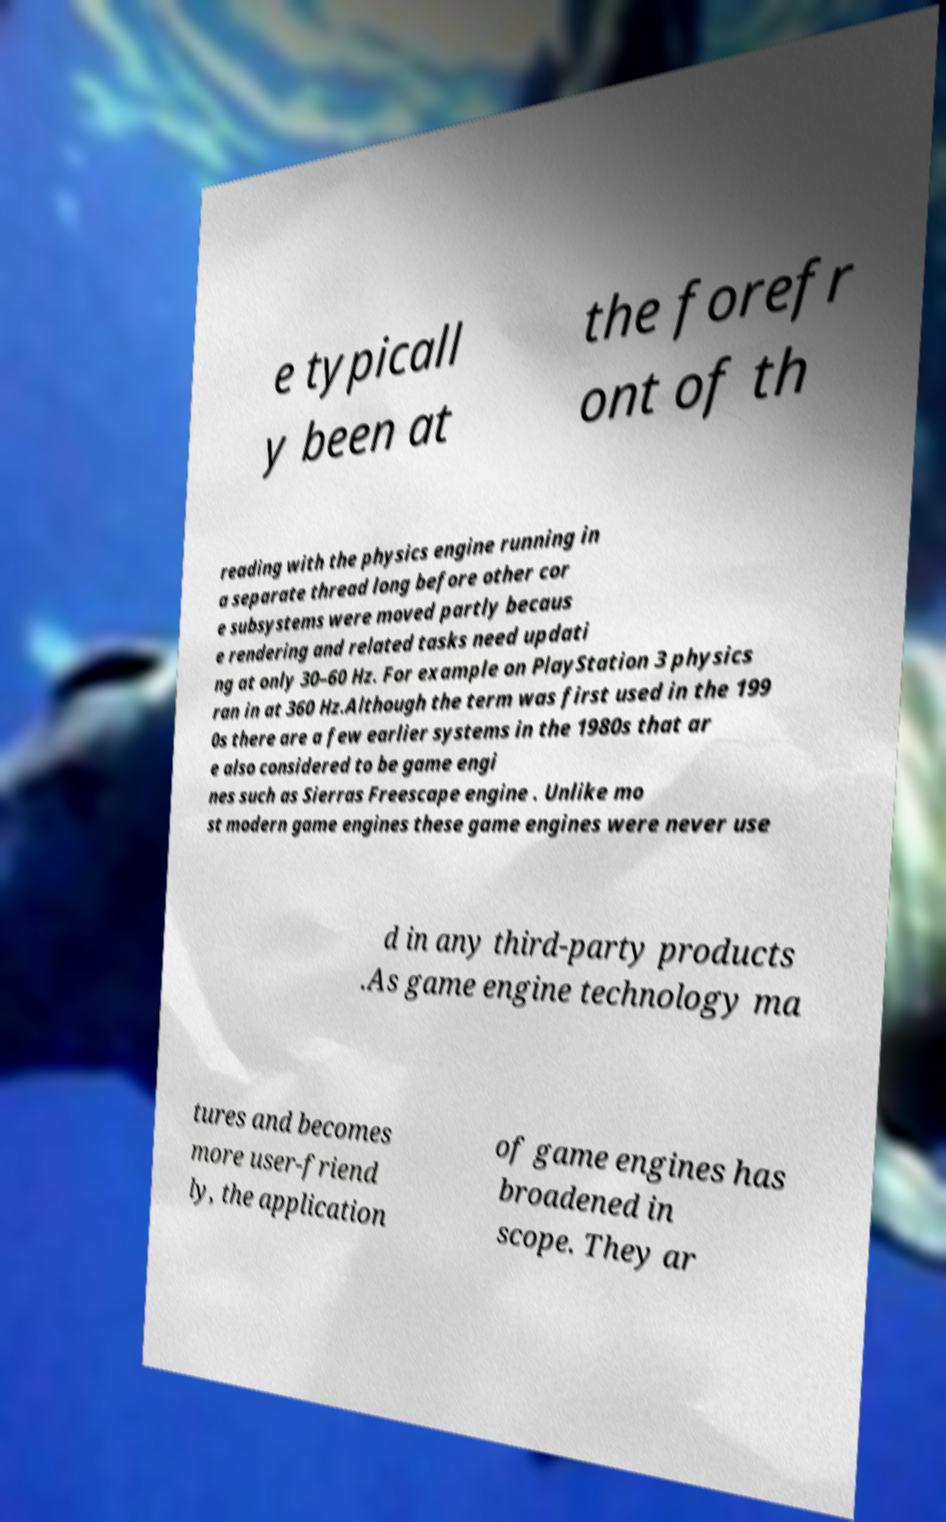Can you read and provide the text displayed in the image?This photo seems to have some interesting text. Can you extract and type it out for me? e typicall y been at the forefr ont of th reading with the physics engine running in a separate thread long before other cor e subsystems were moved partly becaus e rendering and related tasks need updati ng at only 30–60 Hz. For example on PlayStation 3 physics ran in at 360 Hz.Although the term was first used in the 199 0s there are a few earlier systems in the 1980s that ar e also considered to be game engi nes such as Sierras Freescape engine . Unlike mo st modern game engines these game engines were never use d in any third-party products .As game engine technology ma tures and becomes more user-friend ly, the application of game engines has broadened in scope. They ar 